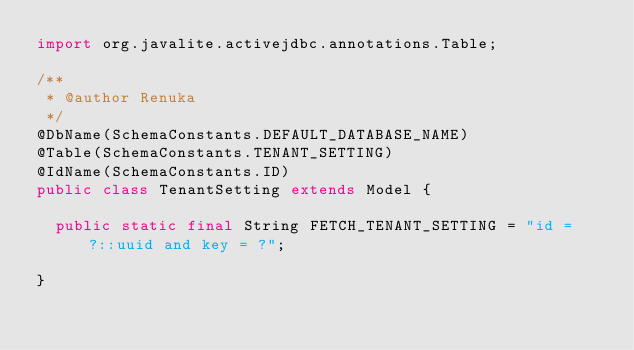<code> <loc_0><loc_0><loc_500><loc_500><_Java_>import org.javalite.activejdbc.annotations.Table;

/**
 * @author Renuka
 */
@DbName(SchemaConstants.DEFAULT_DATABASE_NAME)
@Table(SchemaConstants.TENANT_SETTING)
@IdName(SchemaConstants.ID)
public class TenantSetting extends Model {
  
  public static final String FETCH_TENANT_SETTING = "id = ?::uuid and key = ?";

}
</code> 